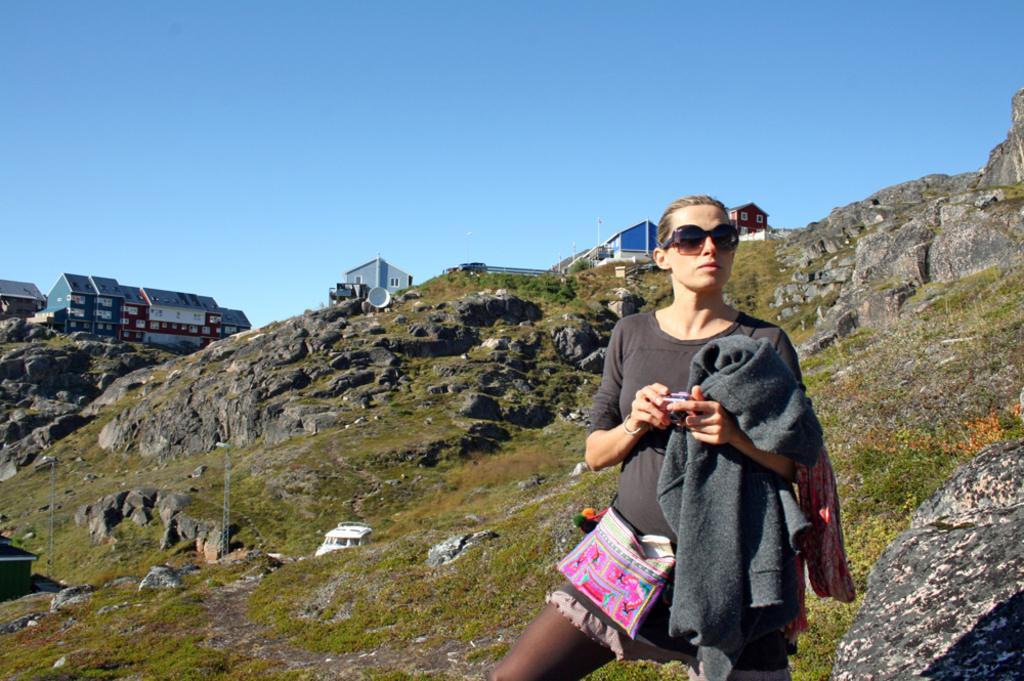Please provide a concise description of this image. In this picture there is a girl wearing grey color t-shirt and holding a hoodie in the hand. Behind there is some trees, mountain and shed houses on the hill. 